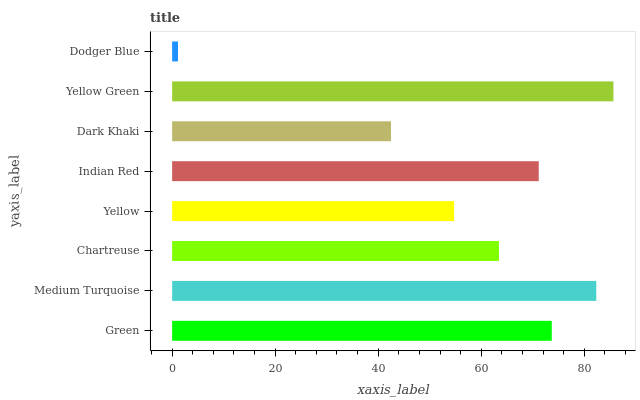Is Dodger Blue the minimum?
Answer yes or no. Yes. Is Yellow Green the maximum?
Answer yes or no. Yes. Is Medium Turquoise the minimum?
Answer yes or no. No. Is Medium Turquoise the maximum?
Answer yes or no. No. Is Medium Turquoise greater than Green?
Answer yes or no. Yes. Is Green less than Medium Turquoise?
Answer yes or no. Yes. Is Green greater than Medium Turquoise?
Answer yes or no. No. Is Medium Turquoise less than Green?
Answer yes or no. No. Is Indian Red the high median?
Answer yes or no. Yes. Is Chartreuse the low median?
Answer yes or no. Yes. Is Green the high median?
Answer yes or no. No. Is Green the low median?
Answer yes or no. No. 